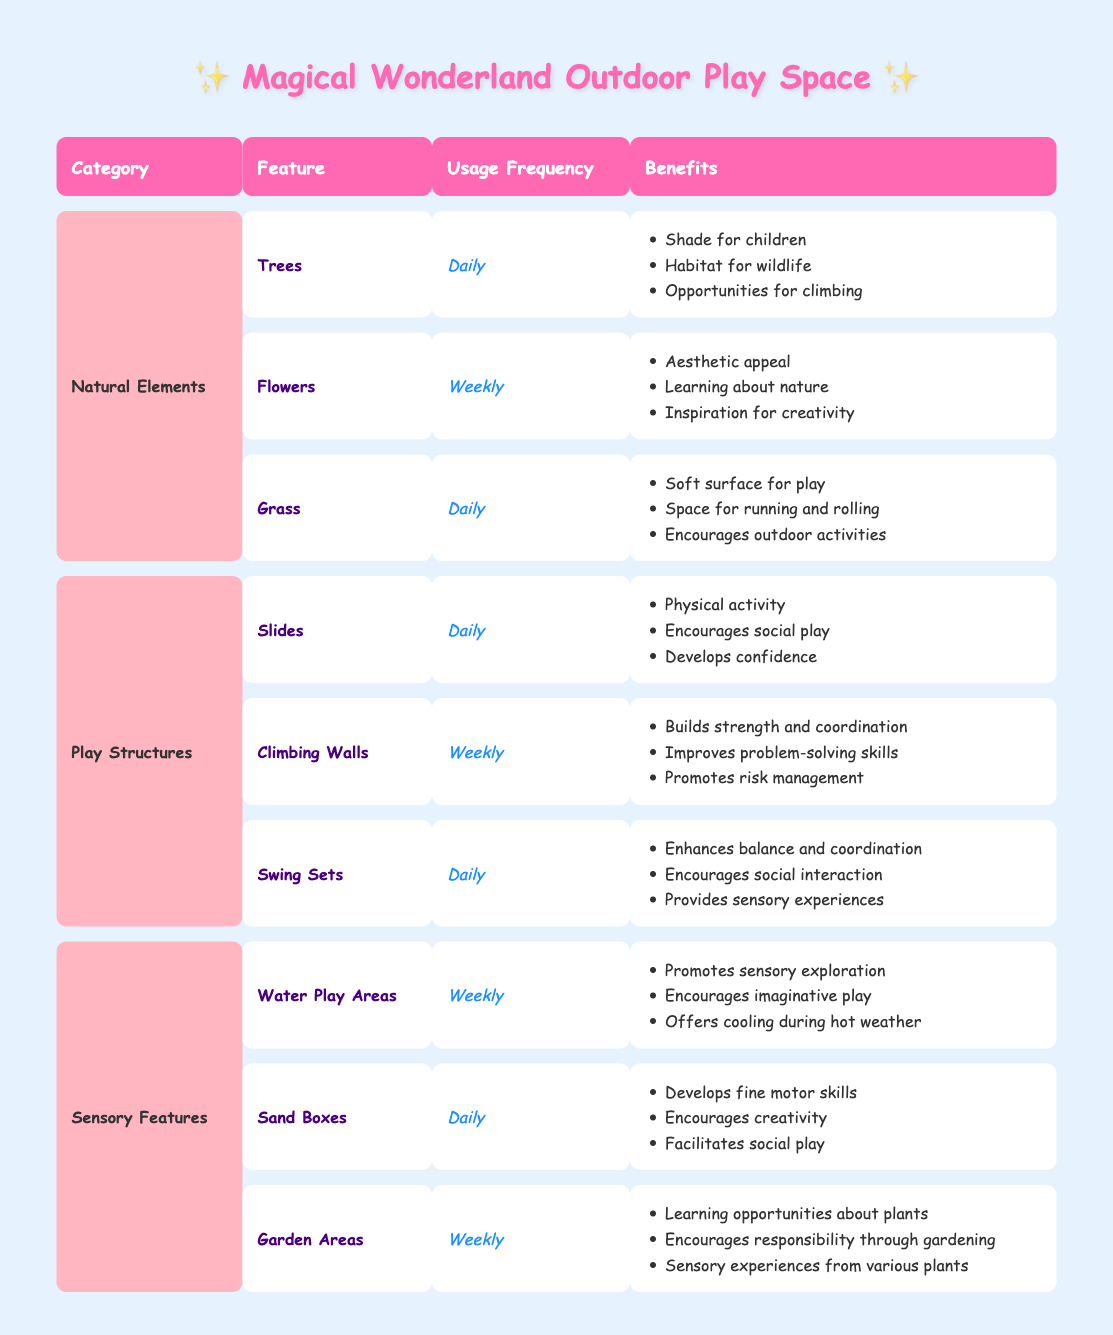What is the usage frequency of Slides? By looking under the "Play Structures" category in the table, the usage frequency for "Slides" is noted to be "Daily."
Answer: Daily How many natural elements are used daily? In the "Natural Elements" category, both "Trees" and "Grass" are listed with a usage frequency of "Daily," totaling two natural elements.
Answer: 2 Do Swing Sets have benefits that involve social interaction? The benefits listed for "Swing Sets" include "Encourages social interaction," indicating that they do indeed have this benefit.
Answer: Yes Which sensory feature has a usage frequency of "Weekly"? In the "Sensory Features" category, both "Water Play Areas" and "Garden Areas" are noted to have a usage frequency of "Weekly."
Answer: Water Play Areas and Garden Areas What is the total number of features that are used daily? By counting the features with a daily usage, we find "Trees," "Grass," "Slides," "Swing Sets," and "Sand Boxes." This totals to five features used daily across the categories.
Answer: 5 Does the "Climbing Walls" feature offer any benefits related to physical activity? The benefits of "Climbing Walls" include "Builds strength and coordination," which relates to physical activity, indicating that it does not directly offer that benefit.
Answer: No How many features encourage social play? "Slides," "Swing Sets," and "Sand Boxes" are the listed features that promote social play. Therefore, three features encourage social play.
Answer: 3 Which natural element has the greatest benefit for wildlife? The "Trees" feature includes "Habitat for wildlife" as one of its benefits, indicating it is specifically designed to support wildlife.
Answer: Trees What is the average frequency for usage across all sensory features? "Sand Boxes" are used daily, while "Water Play Areas" and "Garden Areas" are both weekly. Converting weekly to a daily value (one week = 7 days), averaging the frequencies yields approximately 3.33 days. Thus, the average usage frequency for sensory features is about 3.33 days.
Answer: 3.33 days 